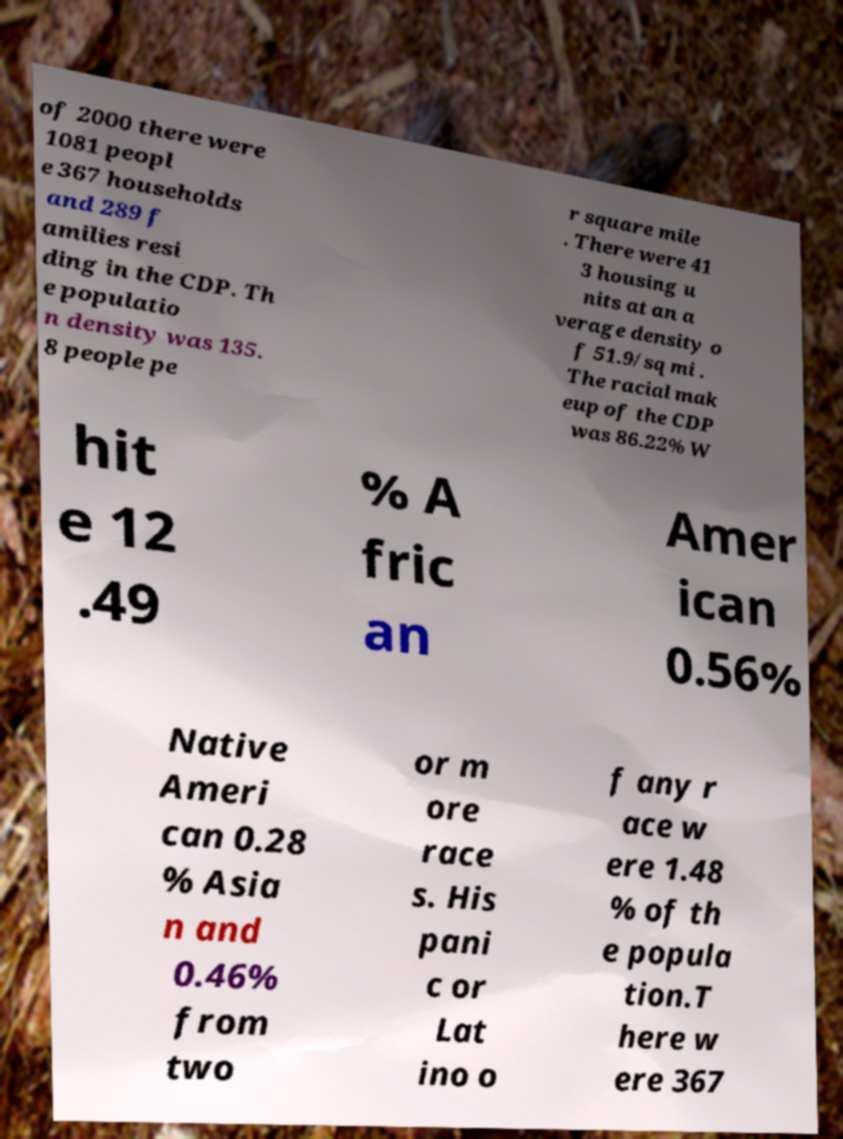Can you accurately transcribe the text from the provided image for me? of 2000 there were 1081 peopl e 367 households and 289 f amilies resi ding in the CDP. Th e populatio n density was 135. 8 people pe r square mile . There were 41 3 housing u nits at an a verage density o f 51.9/sq mi . The racial mak eup of the CDP was 86.22% W hit e 12 .49 % A fric an Amer ican 0.56% Native Ameri can 0.28 % Asia n and 0.46% from two or m ore race s. His pani c or Lat ino o f any r ace w ere 1.48 % of th e popula tion.T here w ere 367 